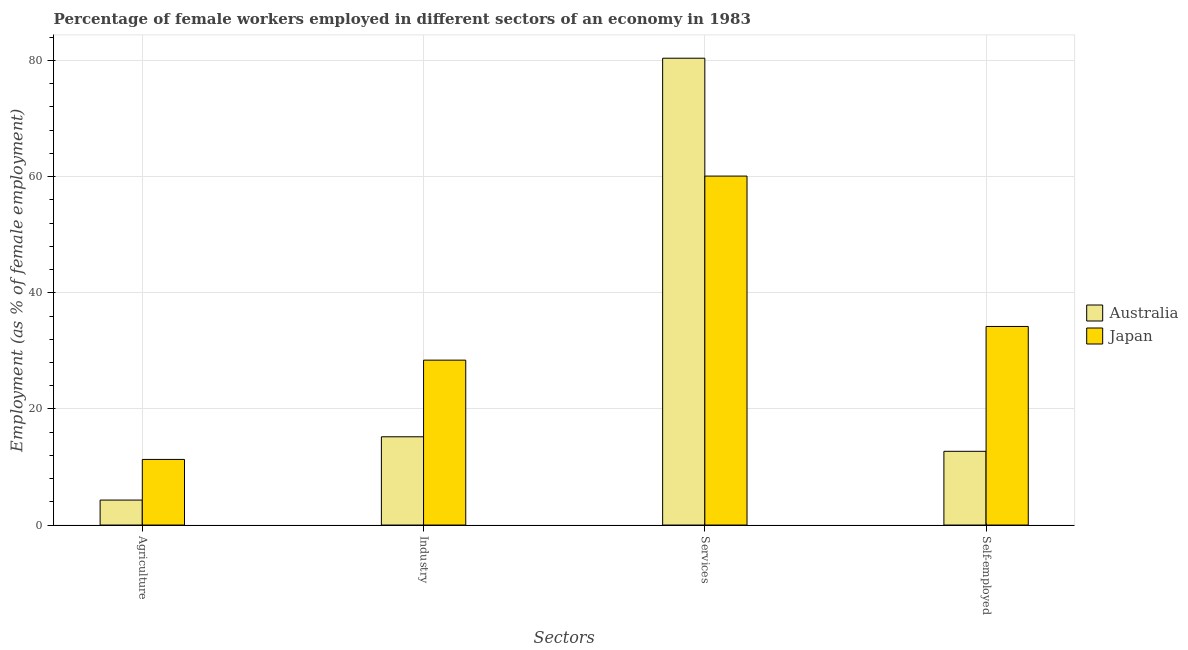Are the number of bars on each tick of the X-axis equal?
Provide a short and direct response. Yes. How many bars are there on the 1st tick from the right?
Make the answer very short. 2. What is the label of the 4th group of bars from the left?
Provide a short and direct response. Self-employed. What is the percentage of female workers in services in Japan?
Your response must be concise. 60.1. Across all countries, what is the maximum percentage of female workers in services?
Your answer should be very brief. 80.4. Across all countries, what is the minimum percentage of self employed female workers?
Your answer should be very brief. 12.7. What is the total percentage of female workers in agriculture in the graph?
Your answer should be compact. 15.6. What is the difference between the percentage of female workers in industry in Australia and that in Japan?
Make the answer very short. -13.2. What is the difference between the percentage of female workers in industry in Australia and the percentage of female workers in services in Japan?
Provide a short and direct response. -44.9. What is the average percentage of self employed female workers per country?
Give a very brief answer. 23.45. What is the difference between the percentage of female workers in agriculture and percentage of female workers in industry in Japan?
Your response must be concise. -17.1. What is the ratio of the percentage of self employed female workers in Japan to that in Australia?
Your answer should be very brief. 2.69. Is the percentage of female workers in services in Australia less than that in Japan?
Ensure brevity in your answer.  No. What is the difference between the highest and the second highest percentage of female workers in agriculture?
Offer a very short reply. 7. What is the difference between the highest and the lowest percentage of self employed female workers?
Provide a short and direct response. 21.5. What does the 1st bar from the left in Services represents?
Your answer should be very brief. Australia. Are the values on the major ticks of Y-axis written in scientific E-notation?
Offer a terse response. No. Does the graph contain any zero values?
Give a very brief answer. No. How are the legend labels stacked?
Provide a short and direct response. Vertical. What is the title of the graph?
Give a very brief answer. Percentage of female workers employed in different sectors of an economy in 1983. Does "Poland" appear as one of the legend labels in the graph?
Provide a succinct answer. No. What is the label or title of the X-axis?
Your answer should be compact. Sectors. What is the label or title of the Y-axis?
Provide a succinct answer. Employment (as % of female employment). What is the Employment (as % of female employment) of Australia in Agriculture?
Offer a terse response. 4.3. What is the Employment (as % of female employment) in Japan in Agriculture?
Give a very brief answer. 11.3. What is the Employment (as % of female employment) in Australia in Industry?
Offer a terse response. 15.2. What is the Employment (as % of female employment) of Japan in Industry?
Your answer should be very brief. 28.4. What is the Employment (as % of female employment) of Australia in Services?
Offer a terse response. 80.4. What is the Employment (as % of female employment) in Japan in Services?
Provide a succinct answer. 60.1. What is the Employment (as % of female employment) of Australia in Self-employed?
Your answer should be very brief. 12.7. What is the Employment (as % of female employment) in Japan in Self-employed?
Give a very brief answer. 34.2. Across all Sectors, what is the maximum Employment (as % of female employment) in Australia?
Provide a succinct answer. 80.4. Across all Sectors, what is the maximum Employment (as % of female employment) of Japan?
Offer a terse response. 60.1. Across all Sectors, what is the minimum Employment (as % of female employment) in Australia?
Make the answer very short. 4.3. Across all Sectors, what is the minimum Employment (as % of female employment) in Japan?
Offer a terse response. 11.3. What is the total Employment (as % of female employment) of Australia in the graph?
Give a very brief answer. 112.6. What is the total Employment (as % of female employment) in Japan in the graph?
Ensure brevity in your answer.  134. What is the difference between the Employment (as % of female employment) of Australia in Agriculture and that in Industry?
Give a very brief answer. -10.9. What is the difference between the Employment (as % of female employment) in Japan in Agriculture and that in Industry?
Your answer should be compact. -17.1. What is the difference between the Employment (as % of female employment) of Australia in Agriculture and that in Services?
Give a very brief answer. -76.1. What is the difference between the Employment (as % of female employment) in Japan in Agriculture and that in Services?
Your response must be concise. -48.8. What is the difference between the Employment (as % of female employment) of Japan in Agriculture and that in Self-employed?
Offer a very short reply. -22.9. What is the difference between the Employment (as % of female employment) of Australia in Industry and that in Services?
Offer a very short reply. -65.2. What is the difference between the Employment (as % of female employment) of Japan in Industry and that in Services?
Keep it short and to the point. -31.7. What is the difference between the Employment (as % of female employment) in Japan in Industry and that in Self-employed?
Provide a succinct answer. -5.8. What is the difference between the Employment (as % of female employment) of Australia in Services and that in Self-employed?
Provide a short and direct response. 67.7. What is the difference between the Employment (as % of female employment) of Japan in Services and that in Self-employed?
Your answer should be compact. 25.9. What is the difference between the Employment (as % of female employment) of Australia in Agriculture and the Employment (as % of female employment) of Japan in Industry?
Ensure brevity in your answer.  -24.1. What is the difference between the Employment (as % of female employment) of Australia in Agriculture and the Employment (as % of female employment) of Japan in Services?
Your answer should be compact. -55.8. What is the difference between the Employment (as % of female employment) of Australia in Agriculture and the Employment (as % of female employment) of Japan in Self-employed?
Keep it short and to the point. -29.9. What is the difference between the Employment (as % of female employment) of Australia in Industry and the Employment (as % of female employment) of Japan in Services?
Offer a very short reply. -44.9. What is the difference between the Employment (as % of female employment) in Australia in Services and the Employment (as % of female employment) in Japan in Self-employed?
Offer a terse response. 46.2. What is the average Employment (as % of female employment) of Australia per Sectors?
Provide a short and direct response. 28.15. What is the average Employment (as % of female employment) of Japan per Sectors?
Offer a terse response. 33.5. What is the difference between the Employment (as % of female employment) in Australia and Employment (as % of female employment) in Japan in Industry?
Provide a short and direct response. -13.2. What is the difference between the Employment (as % of female employment) of Australia and Employment (as % of female employment) of Japan in Services?
Keep it short and to the point. 20.3. What is the difference between the Employment (as % of female employment) of Australia and Employment (as % of female employment) of Japan in Self-employed?
Keep it short and to the point. -21.5. What is the ratio of the Employment (as % of female employment) of Australia in Agriculture to that in Industry?
Offer a very short reply. 0.28. What is the ratio of the Employment (as % of female employment) in Japan in Agriculture to that in Industry?
Provide a short and direct response. 0.4. What is the ratio of the Employment (as % of female employment) in Australia in Agriculture to that in Services?
Offer a very short reply. 0.05. What is the ratio of the Employment (as % of female employment) of Japan in Agriculture to that in Services?
Provide a short and direct response. 0.19. What is the ratio of the Employment (as % of female employment) in Australia in Agriculture to that in Self-employed?
Your answer should be compact. 0.34. What is the ratio of the Employment (as % of female employment) of Japan in Agriculture to that in Self-employed?
Keep it short and to the point. 0.33. What is the ratio of the Employment (as % of female employment) of Australia in Industry to that in Services?
Your answer should be compact. 0.19. What is the ratio of the Employment (as % of female employment) in Japan in Industry to that in Services?
Offer a very short reply. 0.47. What is the ratio of the Employment (as % of female employment) of Australia in Industry to that in Self-employed?
Make the answer very short. 1.2. What is the ratio of the Employment (as % of female employment) in Japan in Industry to that in Self-employed?
Make the answer very short. 0.83. What is the ratio of the Employment (as % of female employment) in Australia in Services to that in Self-employed?
Your answer should be compact. 6.33. What is the ratio of the Employment (as % of female employment) in Japan in Services to that in Self-employed?
Give a very brief answer. 1.76. What is the difference between the highest and the second highest Employment (as % of female employment) in Australia?
Provide a succinct answer. 65.2. What is the difference between the highest and the second highest Employment (as % of female employment) of Japan?
Offer a terse response. 25.9. What is the difference between the highest and the lowest Employment (as % of female employment) of Australia?
Provide a short and direct response. 76.1. What is the difference between the highest and the lowest Employment (as % of female employment) in Japan?
Offer a very short reply. 48.8. 